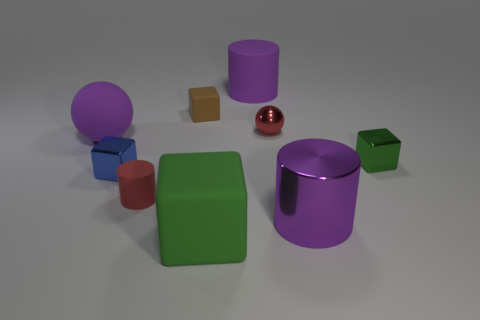Can you guess what the purpose of this image might be? This image appears to serve as a render test or a showcase of 3D modeling capabilities. It demonstrates the application of different materials, reflections, and shades to various geometric shapes. Given the simplicity of the objects and the inclusion of primary colors, it may also be used for educational purposes, such as teaching basic geometry or color theory. 